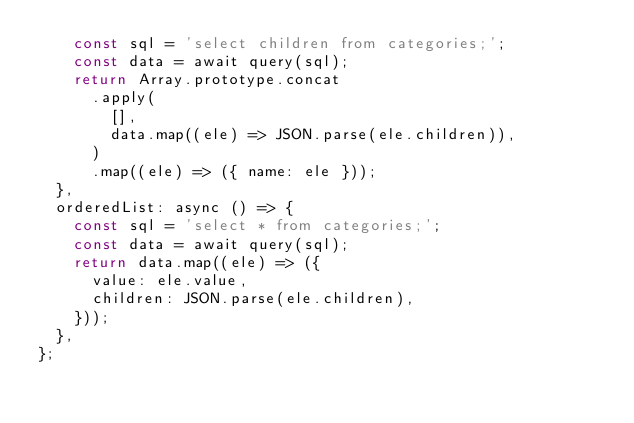<code> <loc_0><loc_0><loc_500><loc_500><_JavaScript_>    const sql = 'select children from categories;';
    const data = await query(sql);
    return Array.prototype.concat
      .apply(
        [],
        data.map((ele) => JSON.parse(ele.children)),
      )
      .map((ele) => ({ name: ele }));
  },
  orderedList: async () => {
    const sql = 'select * from categories;';
    const data = await query(sql);
    return data.map((ele) => ({
      value: ele.value,
      children: JSON.parse(ele.children),
    }));
  },
};
</code> 